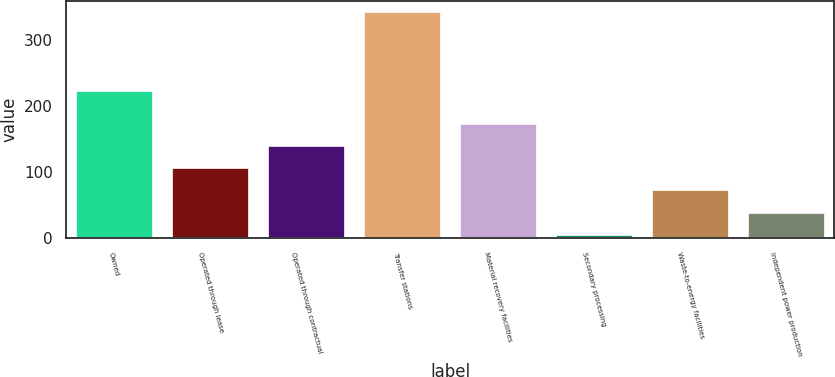<chart> <loc_0><loc_0><loc_500><loc_500><bar_chart><fcel>Owned<fcel>Operated through lease<fcel>Operated through contractual<fcel>Transfer stations<fcel>Material recovery facilities<fcel>Secondary processing<fcel>Waste-to-energy facilities<fcel>Independent power production<nl><fcel>223<fcel>106.1<fcel>139.8<fcel>342<fcel>173.5<fcel>5<fcel>72.4<fcel>38.7<nl></chart> 